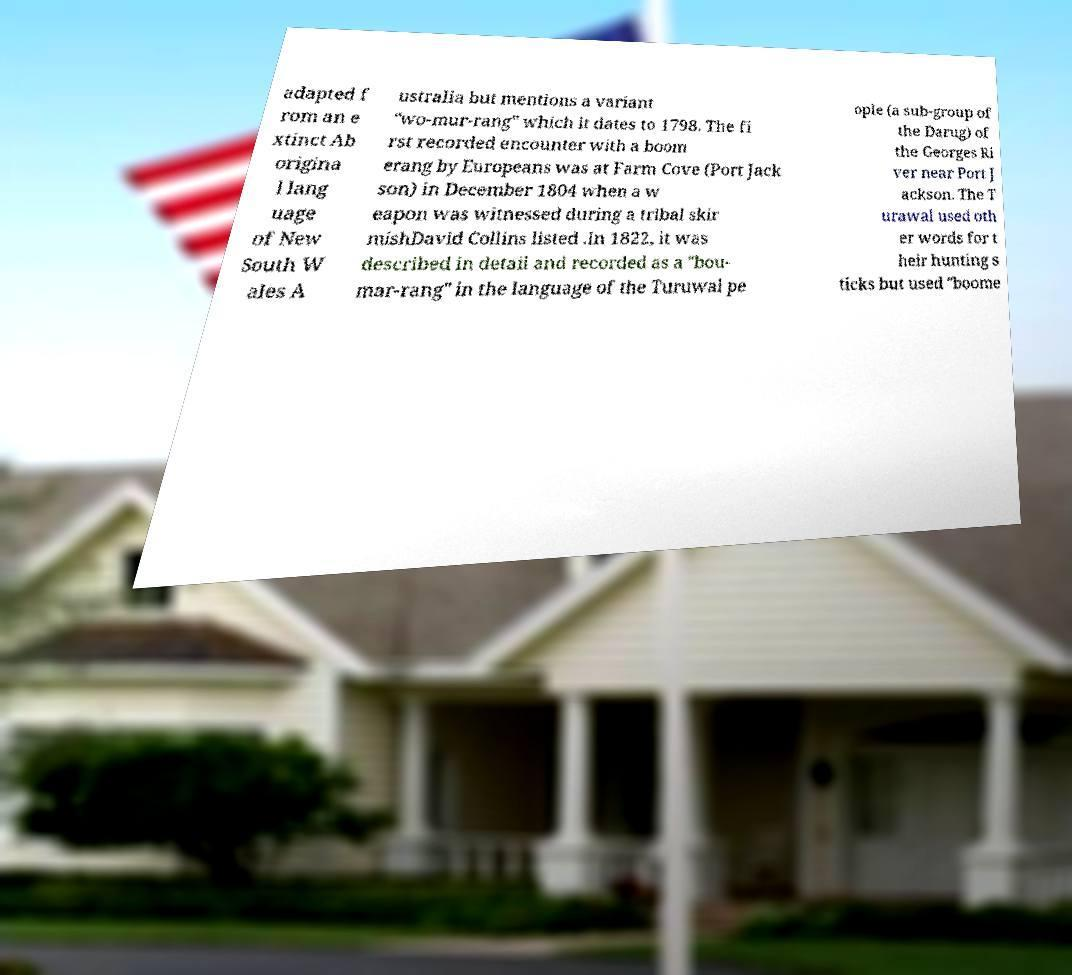There's text embedded in this image that I need extracted. Can you transcribe it verbatim? adapted f rom an e xtinct Ab origina l lang uage of New South W ales A ustralia but mentions a variant "wo-mur-rang" which it dates to 1798. The fi rst recorded encounter with a boom erang by Europeans was at Farm Cove (Port Jack son) in December 1804 when a w eapon was witnessed during a tribal skir mishDavid Collins listed .In 1822, it was described in detail and recorded as a "bou- mar-rang" in the language of the Turuwal pe ople (a sub-group of the Darug) of the Georges Ri ver near Port J ackson. The T urawal used oth er words for t heir hunting s ticks but used "boome 